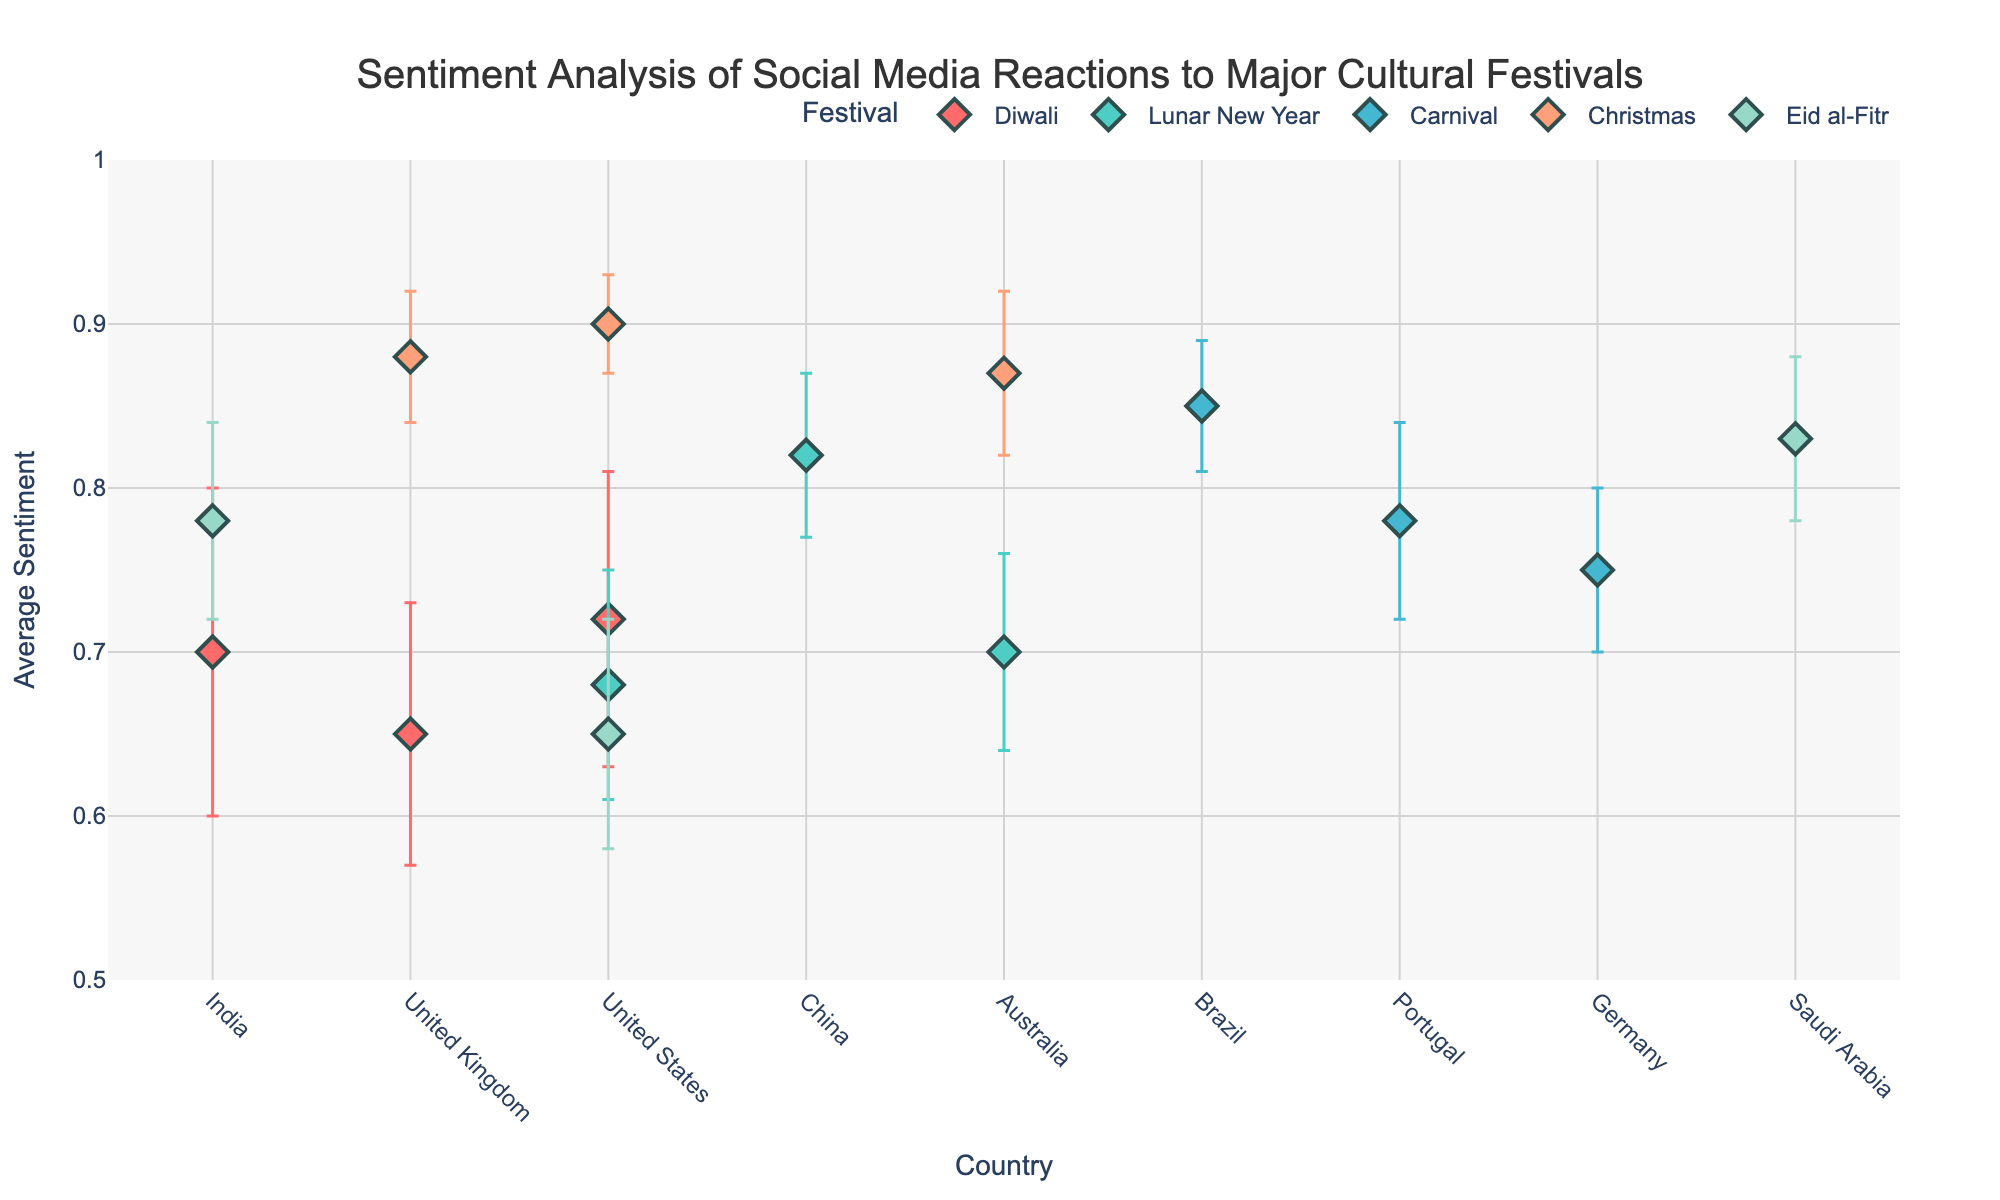What is the title of the dot plot? The title of the dot plot is located at the top center of the figure. It reads: "Sentiment Analysis of Social Media Reactions to Major Cultural Festivals".
Answer: Sentiment Analysis of Social Media Reactions to Major Cultural Festivals Which festival has the highest average sentiment in any country? By observing the y-axis values for different festivals, the highest average sentiment is for Christmas in the United States where the sentiment value is 0.9.
Answer: Christmas in the United States What is the range of the y-axis in the plot? The y-axis, labeled “Average Sentiment”, displays values ranging from 0.5 to 1.
Answer: 0.5 to 1 How does the average sentiment of Christmas in Australia compare to that in the United Kingdom? The average sentiment for Christmas in Australia is 0.87, while in the United Kingdom it is 0.88. The values are very close, with the sentiment in the United Kingdom slightly higher than in Australia.
Answer: United Kingdom is higher Among countries celebrating Diwali, which one has the lowest average sentiment? Reviewing the average sentiment values for Diwali, the United Kingdom has the lowest average sentiment with a value of 0.65.
Answer: United Kingdom Which festival shows the smallest error margin in any country? The smallest error margin is associated with Christmas in the United States where the margin is 0.03.
Answer: Christmas in the United States What is the combined average sentiment for Lunar New Year across all listed countries? The average sentiments for Lunar New Year are 0.82 (China), 0.68 (United States), and 0.7 (Australia). Adding these values gives 0.82 + 0.68 + 0.7 = 2.20, and dividing by 3 for the average gives approximately 0.73.
Answer: 0.73 Which country has the greatest variation in sentiment for Eid al-Fitr, based on the error margins? The countries celebrating Eid al-Fitr are Saudi Arabia (0.05), India (0.06), and the United States (0.07). The United States has the largest error margin of 0.07, indicating the greatest variation.
Answer: United States Compare the sentiment error margins for Carnival between Brazil and Germany. Which one is lower? The error margin for Carnival is 0.04 in Brazil and 0.05 in Germany. Brazil has the lower error margin.
Answer: Brazil Is there any country where the error margin for the same festival is the same? If yes, which one? By looking through the error margins, we see that no country has the same error margin for different instances of the same festival. Each error margin is unique per country and festival.
Answer: No 